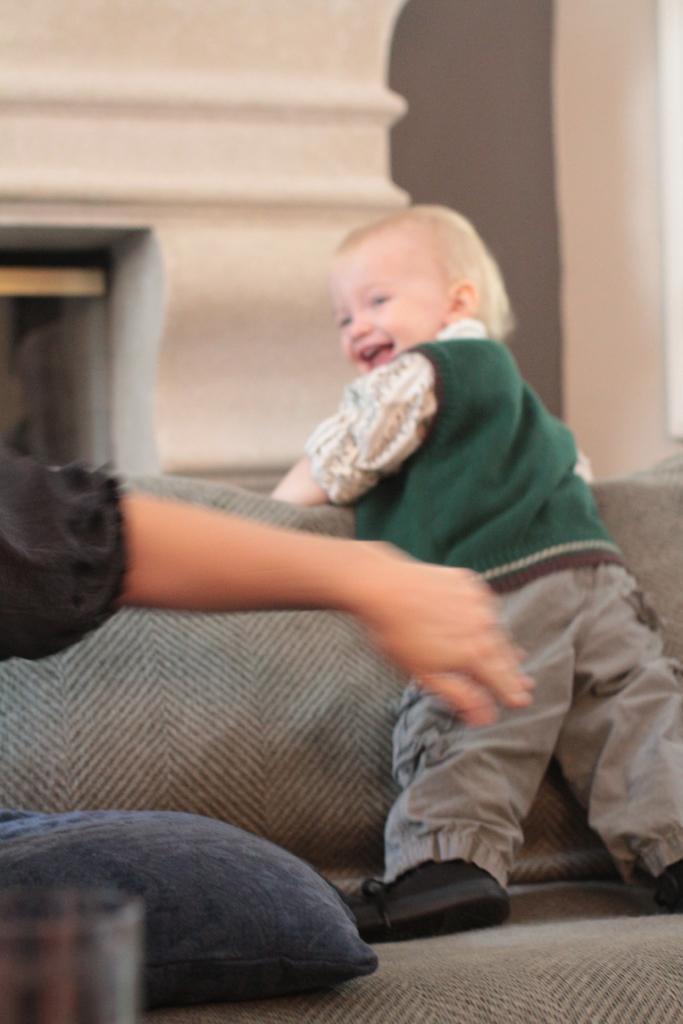Can you describe this image briefly? Here we can see a kid standing on the sofa and smiling. On the left we can see a person hand,glass and a pillow on the sofa. In the background we can see wall and an object. 